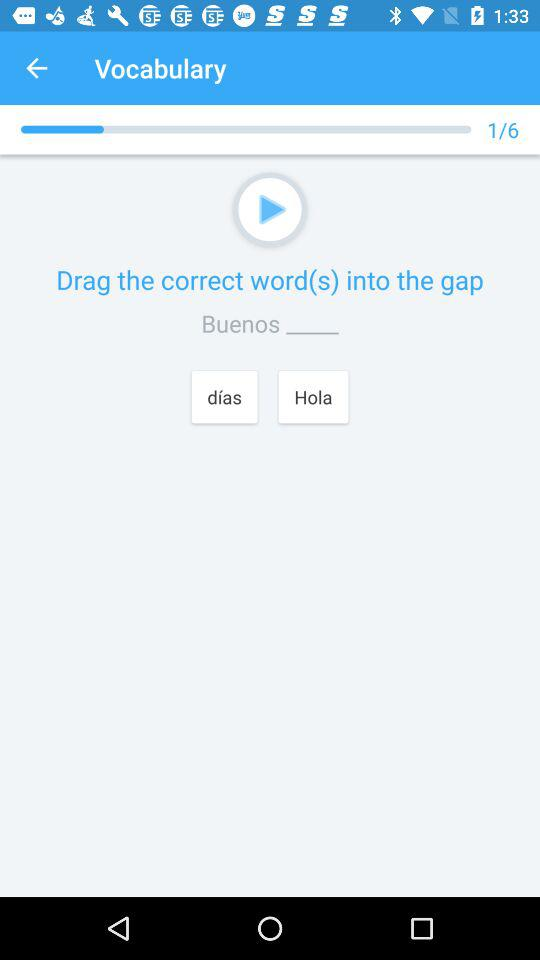At what question am I on? You are at question no. 1. 